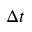Convert formula to latex. <formula><loc_0><loc_0><loc_500><loc_500>\Delta t</formula> 